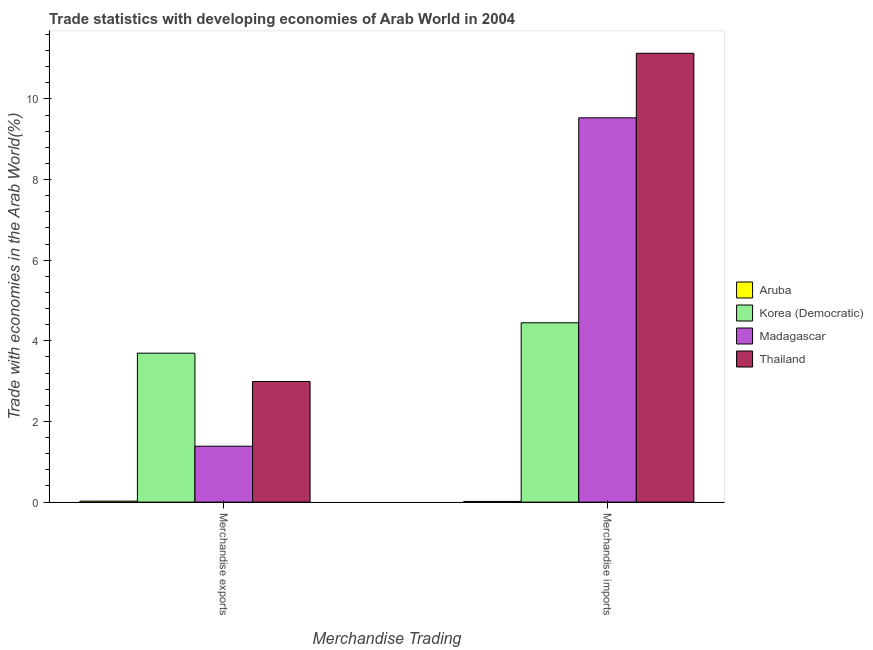How many different coloured bars are there?
Your answer should be compact. 4. Are the number of bars per tick equal to the number of legend labels?
Provide a succinct answer. Yes. Are the number of bars on each tick of the X-axis equal?
Keep it short and to the point. Yes. How many bars are there on the 1st tick from the right?
Provide a short and direct response. 4. What is the label of the 2nd group of bars from the left?
Keep it short and to the point. Merchandise imports. What is the merchandise exports in Aruba?
Your answer should be very brief. 0.03. Across all countries, what is the maximum merchandise exports?
Your answer should be very brief. 3.69. Across all countries, what is the minimum merchandise imports?
Your answer should be very brief. 0.02. In which country was the merchandise exports maximum?
Provide a succinct answer. Korea (Democratic). In which country was the merchandise imports minimum?
Provide a succinct answer. Aruba. What is the total merchandise imports in the graph?
Give a very brief answer. 25.13. What is the difference between the merchandise imports in Aruba and that in Madagascar?
Keep it short and to the point. -9.51. What is the difference between the merchandise exports in Thailand and the merchandise imports in Madagascar?
Provide a short and direct response. -6.54. What is the average merchandise imports per country?
Provide a succinct answer. 6.28. What is the difference between the merchandise imports and merchandise exports in Aruba?
Provide a succinct answer. -0.01. What is the ratio of the merchandise imports in Thailand to that in Aruba?
Keep it short and to the point. 637.12. Is the merchandise imports in Aruba less than that in Thailand?
Make the answer very short. Yes. What does the 1st bar from the left in Merchandise exports represents?
Offer a terse response. Aruba. What does the 2nd bar from the right in Merchandise exports represents?
Your answer should be compact. Madagascar. How many countries are there in the graph?
Offer a terse response. 4. What is the difference between two consecutive major ticks on the Y-axis?
Your response must be concise. 2. Does the graph contain any zero values?
Provide a succinct answer. No. Where does the legend appear in the graph?
Offer a terse response. Center right. What is the title of the graph?
Provide a short and direct response. Trade statistics with developing economies of Arab World in 2004. What is the label or title of the X-axis?
Make the answer very short. Merchandise Trading. What is the label or title of the Y-axis?
Your response must be concise. Trade with economies in the Arab World(%). What is the Trade with economies in the Arab World(%) of Aruba in Merchandise exports?
Keep it short and to the point. 0.03. What is the Trade with economies in the Arab World(%) of Korea (Democratic) in Merchandise exports?
Keep it short and to the point. 3.69. What is the Trade with economies in the Arab World(%) in Madagascar in Merchandise exports?
Make the answer very short. 1.39. What is the Trade with economies in the Arab World(%) of Thailand in Merchandise exports?
Give a very brief answer. 2.99. What is the Trade with economies in the Arab World(%) in Aruba in Merchandise imports?
Give a very brief answer. 0.02. What is the Trade with economies in the Arab World(%) in Korea (Democratic) in Merchandise imports?
Make the answer very short. 4.45. What is the Trade with economies in the Arab World(%) in Madagascar in Merchandise imports?
Provide a short and direct response. 9.53. What is the Trade with economies in the Arab World(%) in Thailand in Merchandise imports?
Give a very brief answer. 11.13. Across all Merchandise Trading, what is the maximum Trade with economies in the Arab World(%) of Aruba?
Your answer should be very brief. 0.03. Across all Merchandise Trading, what is the maximum Trade with economies in the Arab World(%) in Korea (Democratic)?
Offer a very short reply. 4.45. Across all Merchandise Trading, what is the maximum Trade with economies in the Arab World(%) in Madagascar?
Provide a short and direct response. 9.53. Across all Merchandise Trading, what is the maximum Trade with economies in the Arab World(%) of Thailand?
Provide a succinct answer. 11.13. Across all Merchandise Trading, what is the minimum Trade with economies in the Arab World(%) of Aruba?
Provide a short and direct response. 0.02. Across all Merchandise Trading, what is the minimum Trade with economies in the Arab World(%) of Korea (Democratic)?
Ensure brevity in your answer.  3.69. Across all Merchandise Trading, what is the minimum Trade with economies in the Arab World(%) in Madagascar?
Your response must be concise. 1.39. Across all Merchandise Trading, what is the minimum Trade with economies in the Arab World(%) of Thailand?
Your response must be concise. 2.99. What is the total Trade with economies in the Arab World(%) in Aruba in the graph?
Keep it short and to the point. 0.04. What is the total Trade with economies in the Arab World(%) in Korea (Democratic) in the graph?
Your response must be concise. 8.14. What is the total Trade with economies in the Arab World(%) of Madagascar in the graph?
Offer a terse response. 10.92. What is the total Trade with economies in the Arab World(%) in Thailand in the graph?
Your answer should be compact. 14.12. What is the difference between the Trade with economies in the Arab World(%) in Aruba in Merchandise exports and that in Merchandise imports?
Provide a succinct answer. 0.01. What is the difference between the Trade with economies in the Arab World(%) of Korea (Democratic) in Merchandise exports and that in Merchandise imports?
Your answer should be compact. -0.75. What is the difference between the Trade with economies in the Arab World(%) of Madagascar in Merchandise exports and that in Merchandise imports?
Keep it short and to the point. -8.14. What is the difference between the Trade with economies in the Arab World(%) in Thailand in Merchandise exports and that in Merchandise imports?
Ensure brevity in your answer.  -8.14. What is the difference between the Trade with economies in the Arab World(%) in Aruba in Merchandise exports and the Trade with economies in the Arab World(%) in Korea (Democratic) in Merchandise imports?
Give a very brief answer. -4.42. What is the difference between the Trade with economies in the Arab World(%) in Aruba in Merchandise exports and the Trade with economies in the Arab World(%) in Madagascar in Merchandise imports?
Keep it short and to the point. -9.51. What is the difference between the Trade with economies in the Arab World(%) of Aruba in Merchandise exports and the Trade with economies in the Arab World(%) of Thailand in Merchandise imports?
Give a very brief answer. -11.11. What is the difference between the Trade with economies in the Arab World(%) in Korea (Democratic) in Merchandise exports and the Trade with economies in the Arab World(%) in Madagascar in Merchandise imports?
Ensure brevity in your answer.  -5.84. What is the difference between the Trade with economies in the Arab World(%) of Korea (Democratic) in Merchandise exports and the Trade with economies in the Arab World(%) of Thailand in Merchandise imports?
Keep it short and to the point. -7.44. What is the difference between the Trade with economies in the Arab World(%) of Madagascar in Merchandise exports and the Trade with economies in the Arab World(%) of Thailand in Merchandise imports?
Make the answer very short. -9.74. What is the average Trade with economies in the Arab World(%) in Aruba per Merchandise Trading?
Provide a short and direct response. 0.02. What is the average Trade with economies in the Arab World(%) of Korea (Democratic) per Merchandise Trading?
Your answer should be compact. 4.07. What is the average Trade with economies in the Arab World(%) in Madagascar per Merchandise Trading?
Your response must be concise. 5.46. What is the average Trade with economies in the Arab World(%) of Thailand per Merchandise Trading?
Ensure brevity in your answer.  7.06. What is the difference between the Trade with economies in the Arab World(%) of Aruba and Trade with economies in the Arab World(%) of Korea (Democratic) in Merchandise exports?
Your answer should be compact. -3.67. What is the difference between the Trade with economies in the Arab World(%) of Aruba and Trade with economies in the Arab World(%) of Madagascar in Merchandise exports?
Offer a very short reply. -1.36. What is the difference between the Trade with economies in the Arab World(%) in Aruba and Trade with economies in the Arab World(%) in Thailand in Merchandise exports?
Offer a terse response. -2.97. What is the difference between the Trade with economies in the Arab World(%) of Korea (Democratic) and Trade with economies in the Arab World(%) of Madagascar in Merchandise exports?
Provide a short and direct response. 2.31. What is the difference between the Trade with economies in the Arab World(%) of Korea (Democratic) and Trade with economies in the Arab World(%) of Thailand in Merchandise exports?
Offer a very short reply. 0.7. What is the difference between the Trade with economies in the Arab World(%) of Madagascar and Trade with economies in the Arab World(%) of Thailand in Merchandise exports?
Offer a very short reply. -1.6. What is the difference between the Trade with economies in the Arab World(%) of Aruba and Trade with economies in the Arab World(%) of Korea (Democratic) in Merchandise imports?
Your answer should be very brief. -4.43. What is the difference between the Trade with economies in the Arab World(%) of Aruba and Trade with economies in the Arab World(%) of Madagascar in Merchandise imports?
Provide a short and direct response. -9.51. What is the difference between the Trade with economies in the Arab World(%) of Aruba and Trade with economies in the Arab World(%) of Thailand in Merchandise imports?
Offer a very short reply. -11.11. What is the difference between the Trade with economies in the Arab World(%) in Korea (Democratic) and Trade with economies in the Arab World(%) in Madagascar in Merchandise imports?
Your response must be concise. -5.08. What is the difference between the Trade with economies in the Arab World(%) of Korea (Democratic) and Trade with economies in the Arab World(%) of Thailand in Merchandise imports?
Provide a succinct answer. -6.68. What is the difference between the Trade with economies in the Arab World(%) in Madagascar and Trade with economies in the Arab World(%) in Thailand in Merchandise imports?
Offer a very short reply. -1.6. What is the ratio of the Trade with economies in the Arab World(%) in Aruba in Merchandise exports to that in Merchandise imports?
Make the answer very short. 1.45. What is the ratio of the Trade with economies in the Arab World(%) in Korea (Democratic) in Merchandise exports to that in Merchandise imports?
Keep it short and to the point. 0.83. What is the ratio of the Trade with economies in the Arab World(%) of Madagascar in Merchandise exports to that in Merchandise imports?
Give a very brief answer. 0.15. What is the ratio of the Trade with economies in the Arab World(%) in Thailand in Merchandise exports to that in Merchandise imports?
Ensure brevity in your answer.  0.27. What is the difference between the highest and the second highest Trade with economies in the Arab World(%) of Aruba?
Provide a short and direct response. 0.01. What is the difference between the highest and the second highest Trade with economies in the Arab World(%) in Korea (Democratic)?
Make the answer very short. 0.75. What is the difference between the highest and the second highest Trade with economies in the Arab World(%) of Madagascar?
Keep it short and to the point. 8.14. What is the difference between the highest and the second highest Trade with economies in the Arab World(%) in Thailand?
Ensure brevity in your answer.  8.14. What is the difference between the highest and the lowest Trade with economies in the Arab World(%) in Aruba?
Make the answer very short. 0.01. What is the difference between the highest and the lowest Trade with economies in the Arab World(%) of Korea (Democratic)?
Offer a terse response. 0.75. What is the difference between the highest and the lowest Trade with economies in the Arab World(%) in Madagascar?
Ensure brevity in your answer.  8.14. What is the difference between the highest and the lowest Trade with economies in the Arab World(%) in Thailand?
Give a very brief answer. 8.14. 